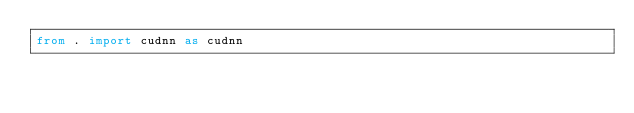<code> <loc_0><loc_0><loc_500><loc_500><_Python_>from . import cudnn as cudnn
</code> 